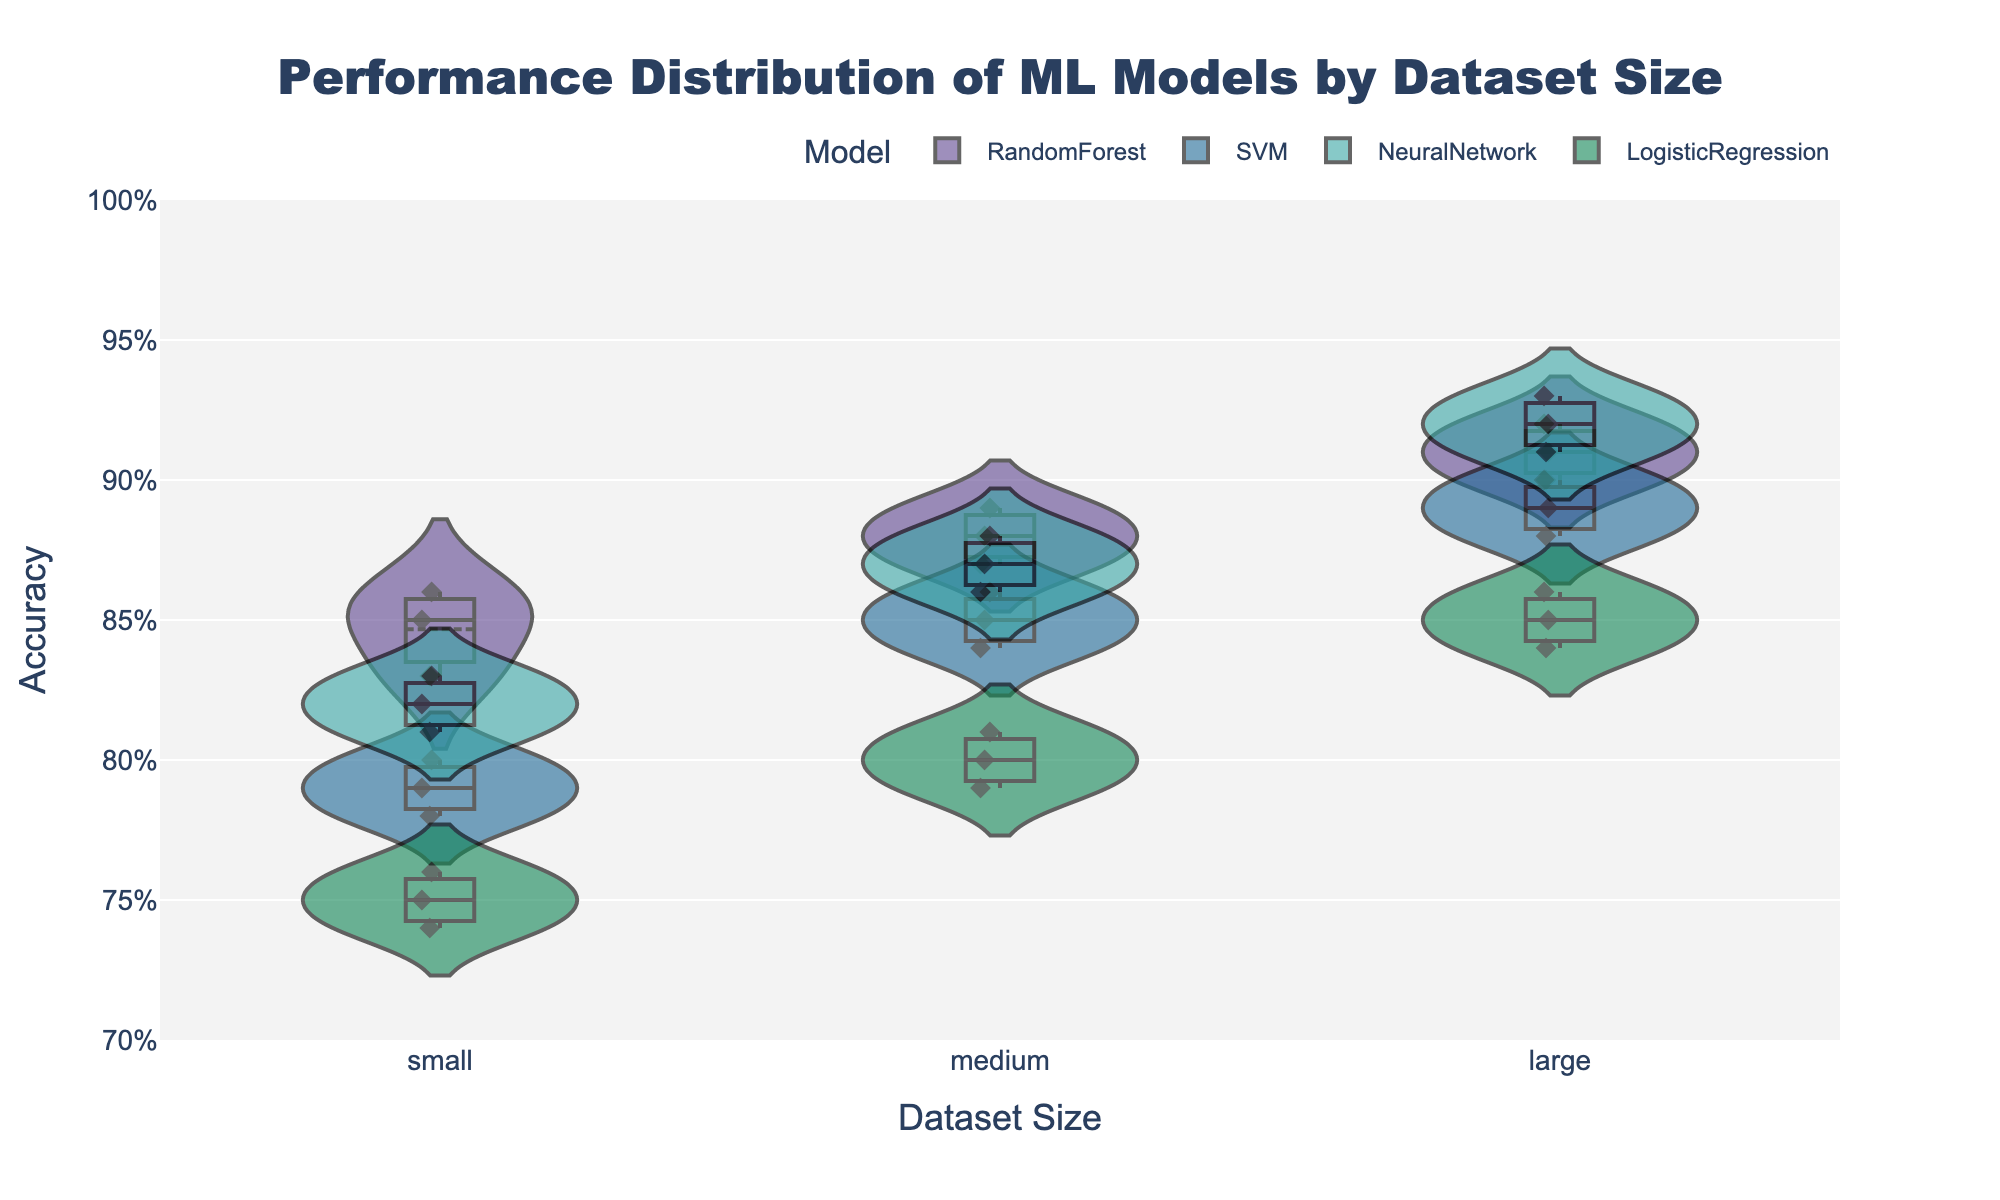What's the title of the figure? The title is displayed prominently at the top of the figure. By reading the title text, we can identify that it is "Performance Distribution of ML Models by Dataset Size".
Answer: Performance Distribution of ML Models by Dataset Size Which model has the highest accuracy distribution for large datasets? To find the model with the highest accuracy distribution for large datasets, we look at the violin plots for the "large" dataset size. The NeuralNetwork plot shows the highest accuracy distribution, indicated by the top of its range and meanline.
Answer: NeuralNetwork How does the accuracy of Logistic Regression compare between small and large dataset sizes? To compare the accuracy of Logistic Regression between small and large datasets, observe the violin plots for LogisticRegression at both dataset sizes. The accuracy is higher for large datasets as depicted by the spread and meanline positions in the violin plots.
Answer: Higher for large datasets Which model shows the smallest variation in accuracy for medium datasets? Examine the spread of the violin plots for each model at the "medium" dataset size. The RandomForest model has the smallest spread, indicating the least variation in accuracy.
Answer: RandomForest What is the range of accuracy values for the SVM model with small datasets? Look at the SVM violin plot for the "small" dataset size to observe the range of values where the violin plot extends. The range is between 0.78 and 0.80.
Answer: 0.78 to 0.80 Which dataset size shows the highest mean accuracy across all models? To find the highest mean accuracy, compare the meanlines for all models across the different dataset sizes. "Large" dataset size has the highest mean accuracy as the meanlines for all models are higher compared to those for "small" and "medium" dataset sizes.
Answer: Large Does the RandomForest model perform better than the SVM model on medium datasets? Comparing the meanlines of the violin plots for RandomForest and SVM models at "medium" dataset size reveals that the meanline for RandomForest is slightly higher than that of the SVM, indicating better performance.
Answer: Yes What is the average accuracy for the NeuralNetwork model on medium datasets? To find the average accuracy, we look at the meanline of the NeuralNetwork violin plot for the "medium" dataset size. The meanline represents the average, which is approximately 0.87.
Answer: 0.87 How do the accuracy distributions of all models compare at the "small" dataset size? Analyze the spread and meanlines of the violin plots for all models at the "small" dataset size. NeuralNetwork and RandomForest show higher and tighter distributions, while LogisticRegression shows the lowest accuracy with a wider distribution. SVM has an intermediate position.
Answer: NeuralNetwork and RandomForest > SVM > LogisticRegression 